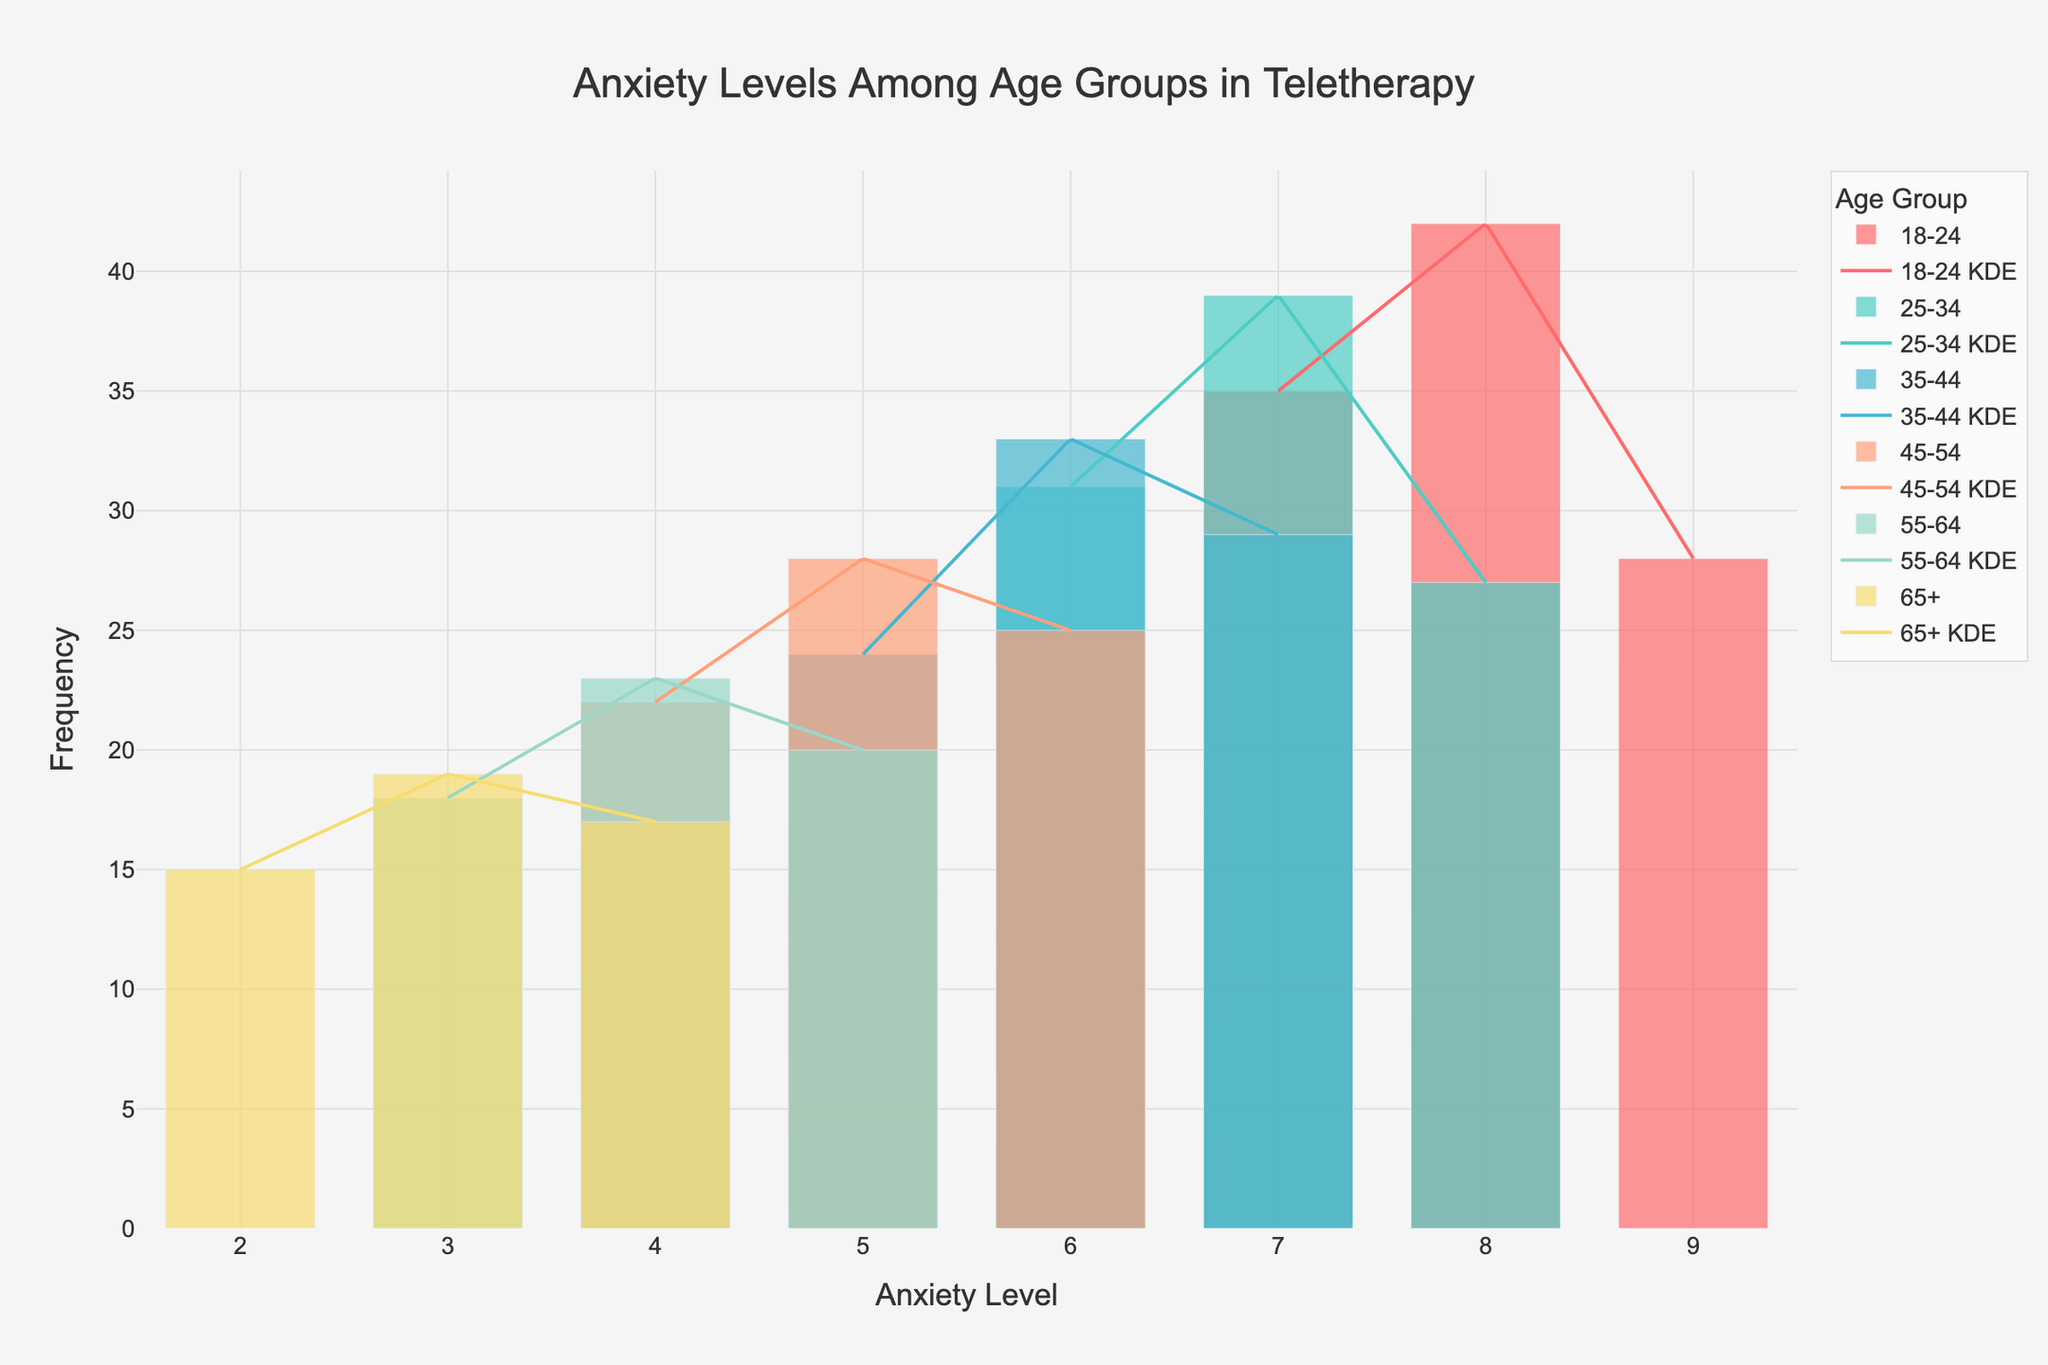What is the title of the figure? The title is displayed at the top of the figure, prominently in a larger font size compared to other text elements. It provides an overview of what the plot is about, summarizing the data being visualized.
Answer: Anxiety Levels Among Age Groups in Teletherapy Which age group has the highest frequency of the highest anxiety level recorded? Look at the bars representing different anxiety levels for each age group. Identify the age group with the highest anxiety level (9) and see which one has the tallest bar.
Answer: 18-24 What is the anxiety level with the highest frequency in the 35-44 age group? Locate the bars for the 35-44 age group. Identify the tallest bar, which represents the anxiety level with the highest frequency.
Answer: 6 Which age group reports the lowest anxiety levels most frequently? Locate the groups where the bars representing the lowest anxiety levels (2 or 3) are tallest. Compare these to determine the group with the highest frequency.
Answer: 65+ Compare the highest frequency of anxiety levels between the 18-24 and 25-34 age groups. Which one is higher and by what difference? Identify the tallest bars for both age groups. Subtract the frequency of the 25-34 group’s highest bar from that of the 18-24 group’s highest bar to get the difference.
Answer: 18-24 is higher by 3 For the age group 45-54, what is the combined frequency of anxiety levels 5 and 6? Locate the bars for anxiety levels 5 and 6 in the 45-54 age group. Sum their frequencies to get the total combined frequency.
Answer: 53 Which age group has the smoothest density curve (KDE) and why could that be? Observe the curves overlaid on the histogram bars. The smoothest curve is the least jagged. This smoothness indicates a more consistent distribution of frequencies across anxiety levels.
Answer: 65+, possibly due to more uniform reporting How does the frequency distribution of anxiety levels vary between the 18-24 and 55-64 age groups? Compare the height and shape of the bars (and the density curves) between the two age groups. Note differences in peak frequencies and overall spread of data across different anxiety levels.
Answer: 18-24 shows higher and more variable frequencies; 55-64 shows lower, more consistent frequencies Which age group shows a peak at anxiety level 4? Look at the heights of the bars for anxiety level 4 across all age groups and identify which one has the tallest bar.
Answer: 55-64 